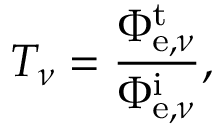<formula> <loc_0><loc_0><loc_500><loc_500>T _ { \nu } = { \frac { \Phi _ { e , \nu } ^ { t } } { \Phi _ { e , \nu } ^ { i } } } ,</formula> 